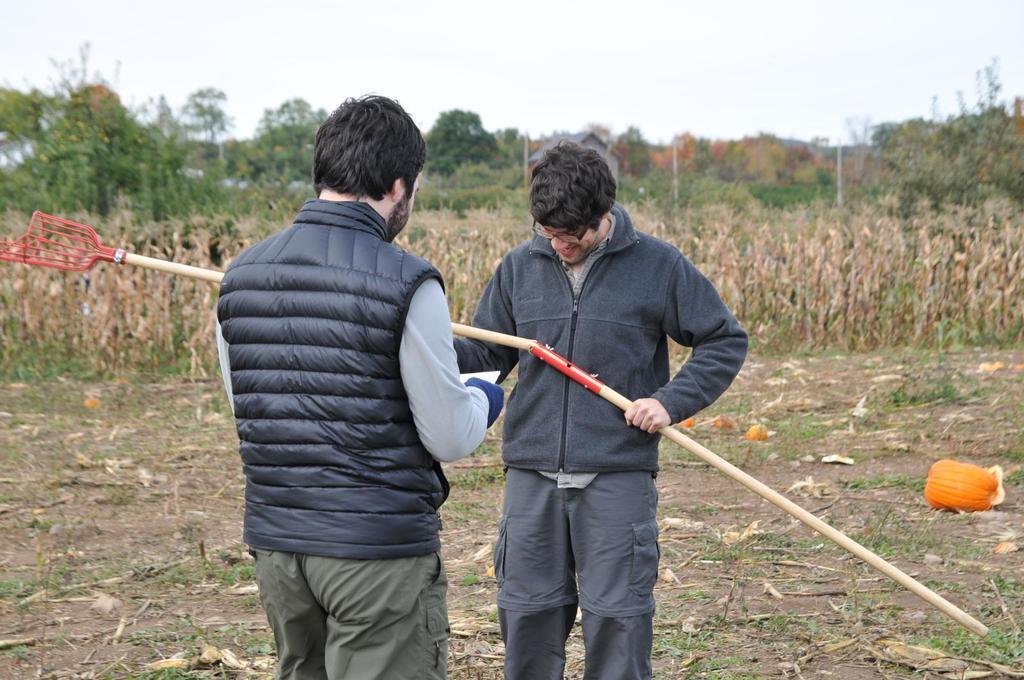Can you describe this image briefly? In this image I can see two persons wearing a black color jackets and one person holding a stick ad standing on the ground at the top I can see the sky and in the middle I can see the grass and trees. 